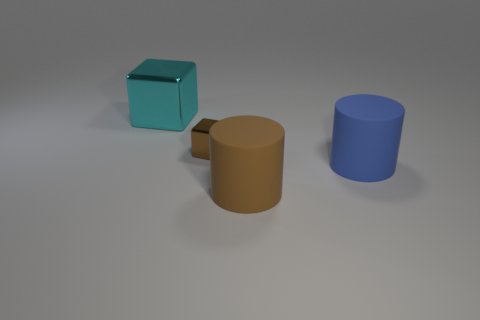There is a large matte thing in front of the large object on the right side of the large rubber cylinder that is in front of the blue object; what shape is it?
Provide a short and direct response. Cylinder. Is the number of blocks that are behind the brown rubber cylinder less than the number of things behind the small brown object?
Keep it short and to the point. No. What is the shape of the large object that is behind the metallic block that is in front of the large cyan object?
Offer a terse response. Cube. Is there any other thing that is the same color as the tiny metal object?
Ensure brevity in your answer.  Yes. What number of blue things are either large cylinders or big metallic things?
Make the answer very short. 1. Are there fewer cylinders that are behind the blue thing than blue objects?
Provide a short and direct response. Yes. There is a metallic thing in front of the cyan shiny cube; how many cyan metal blocks are behind it?
Make the answer very short. 1. What number of other objects are the same size as the cyan thing?
Keep it short and to the point. 2. What number of objects are small gray shiny cylinders or large matte objects behind the brown rubber cylinder?
Offer a very short reply. 1. Is the number of metallic objects less than the number of big gray matte blocks?
Your response must be concise. No. 